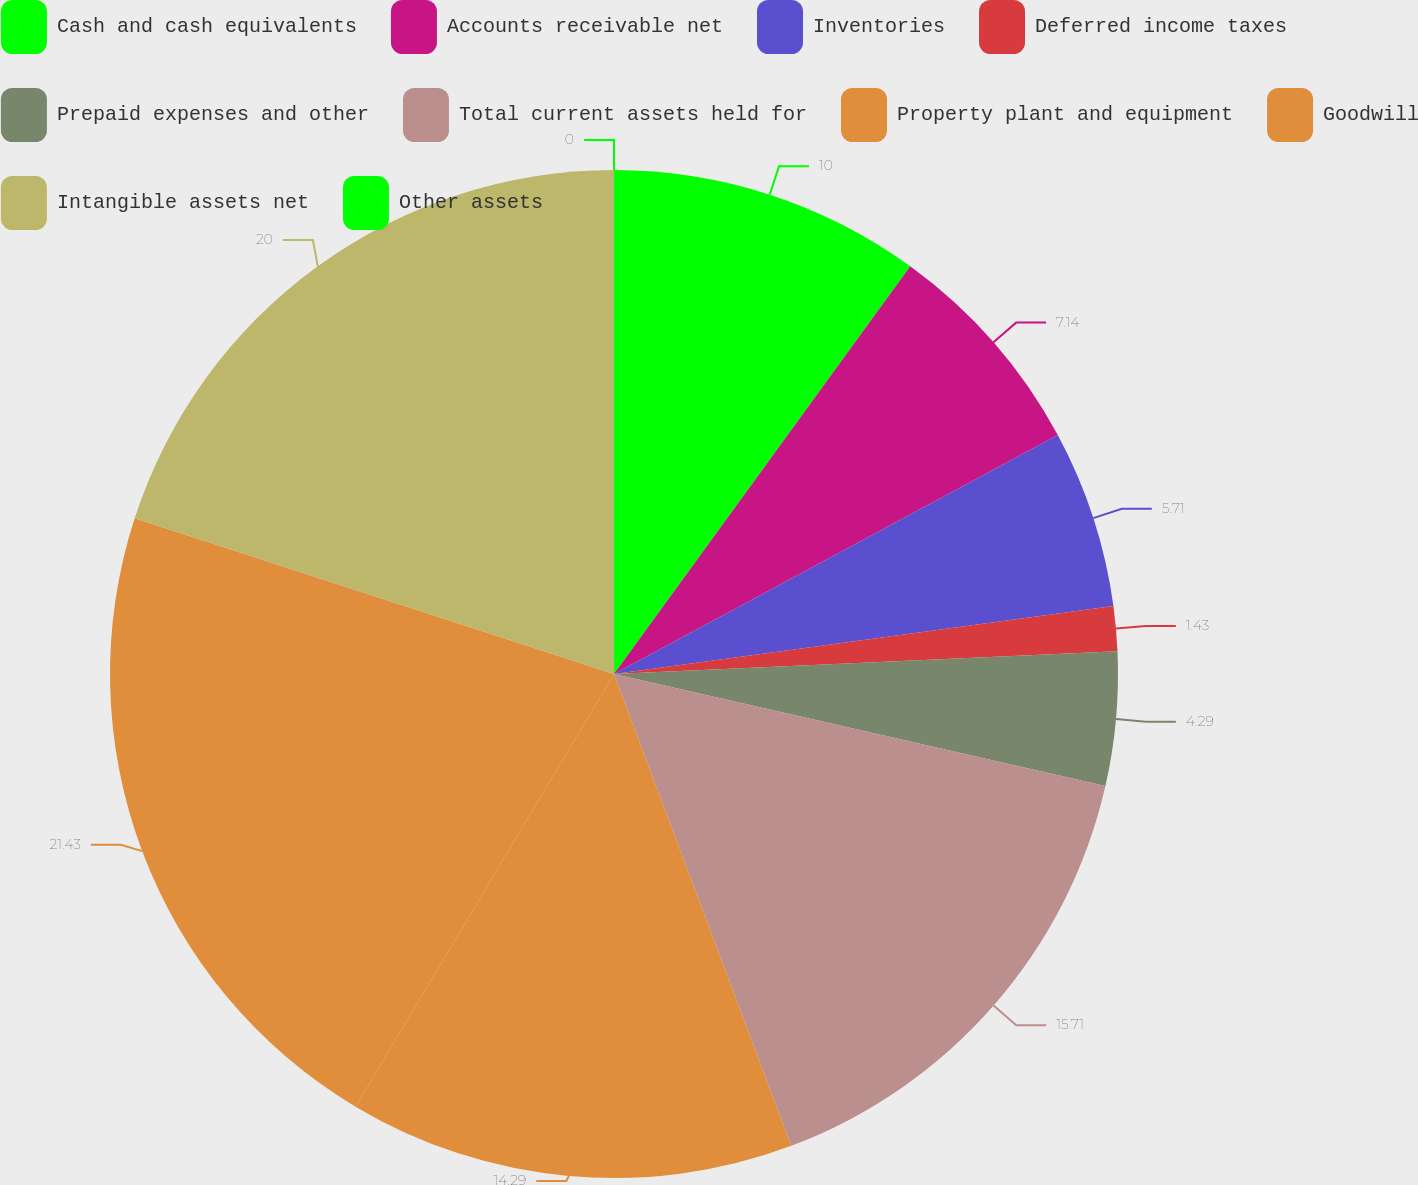Convert chart. <chart><loc_0><loc_0><loc_500><loc_500><pie_chart><fcel>Cash and cash equivalents<fcel>Accounts receivable net<fcel>Inventories<fcel>Deferred income taxes<fcel>Prepaid expenses and other<fcel>Total current assets held for<fcel>Property plant and equipment<fcel>Goodwill<fcel>Intangible assets net<fcel>Other assets<nl><fcel>10.0%<fcel>7.14%<fcel>5.71%<fcel>1.43%<fcel>4.29%<fcel>15.71%<fcel>14.29%<fcel>21.43%<fcel>20.0%<fcel>0.0%<nl></chart> 